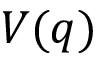<formula> <loc_0><loc_0><loc_500><loc_500>V ( q )</formula> 